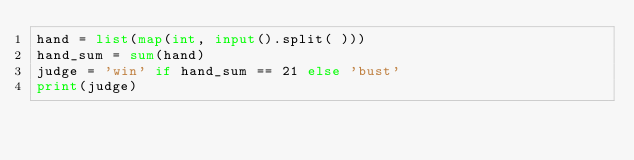<code> <loc_0><loc_0><loc_500><loc_500><_Python_>hand = list(map(int, input().split( )))
hand_sum = sum(hand)
judge = 'win' if hand_sum == 21 else 'bust'
print(judge)</code> 